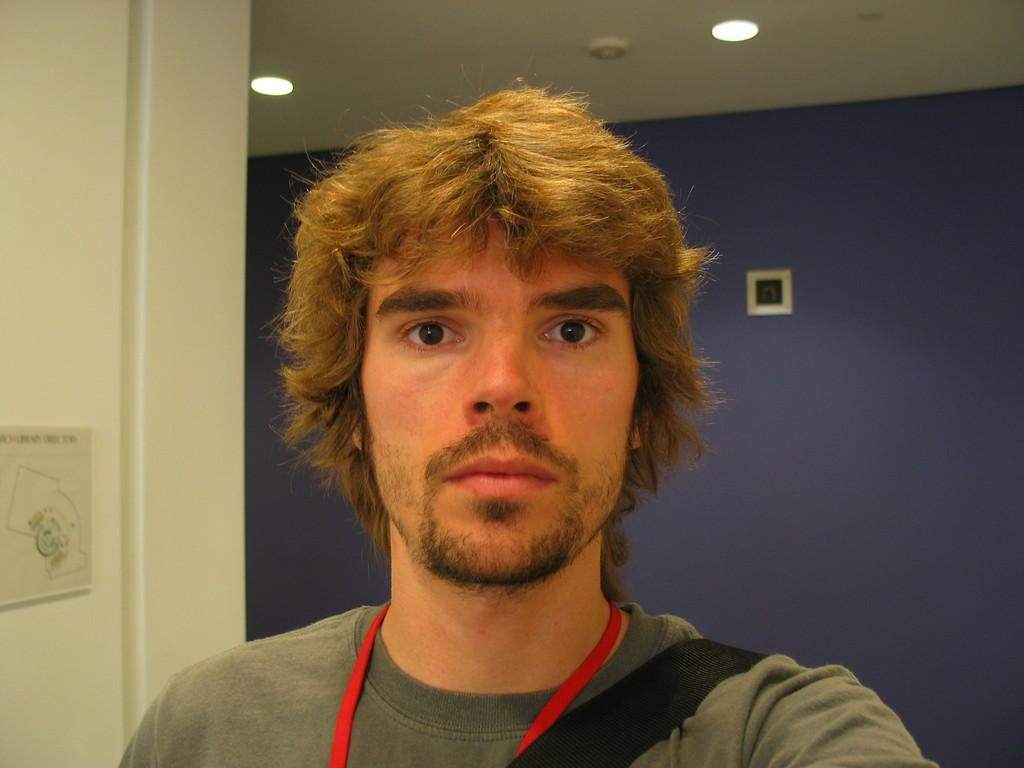Who or what is in the front of the image? There is a person in the front of the image. What can be seen on the wall in the background of the image? There are frames on the wall in the background of the image. What is visible at the top of the image? There are lights visible at the top of the image. What type of grass is growing on the cart in the image? There is no cart or grass present in the image. 